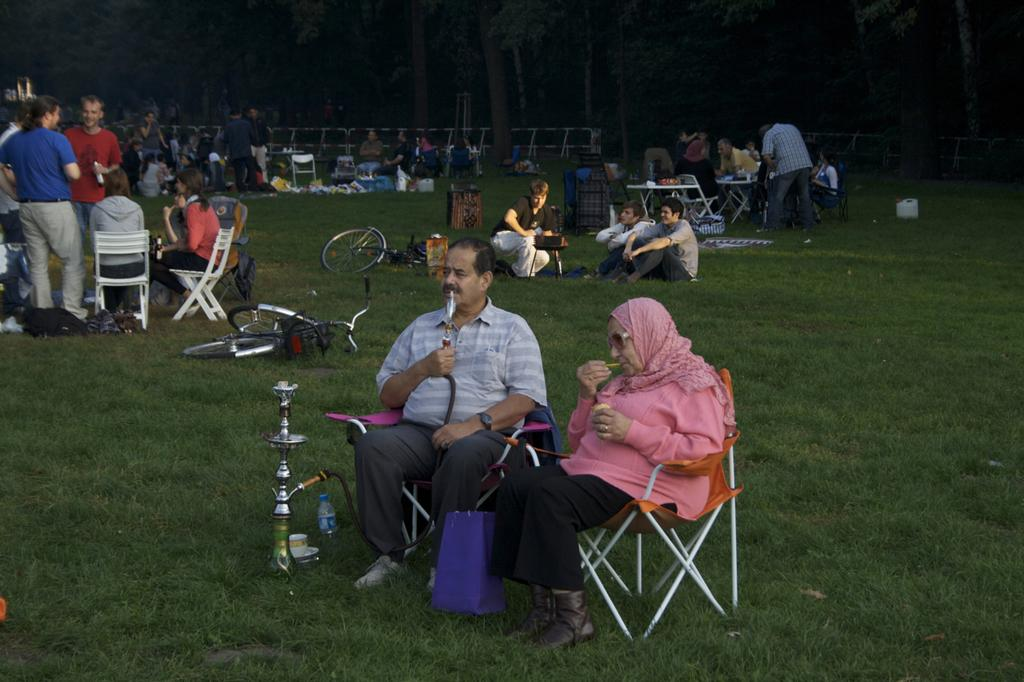How many people are sitting in chairs in the image? There are two persons sitting in chairs in the image. What object is in front of the two persons? There is a hookah pot in front of the two persons. What can be seen in the background of the image? There is a group of people and trees in the background. What is the ground covered with in the image? The ground appears to be covered in greenery. Can you see a thumb in the image? There is no thumb visible in the image. What type of toothbrush is being used by the persons in the image? There is no toothbrush present in the image. 